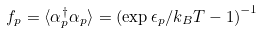<formula> <loc_0><loc_0><loc_500><loc_500>f _ { p } = \langle \alpha _ { p } ^ { \dagger } \alpha _ { p } \rangle = \left ( \exp { \epsilon _ { p } / k _ { B } T } - 1 \right ) ^ { - 1 }</formula> 